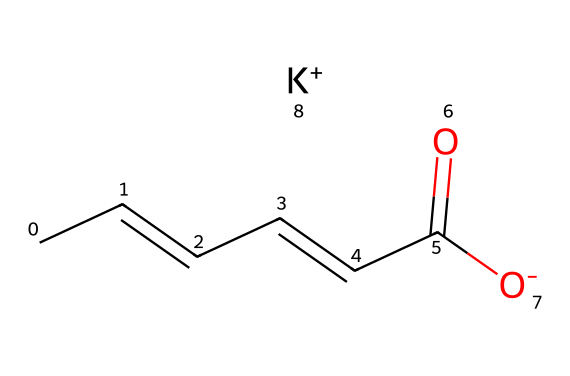What is the name of this chemical? The structural formula provided corresponds to a chemical known as potassium sorbate, which is commonly used as a preservative.
Answer: potassium sorbate How many carbon atoms are in potassium sorbate? By analyzing the SMILES representation, we can count the "C" labels, which indicate the presence of carbon atoms. In this case, there are 6 carbon atoms present in the structure of potassium sorbate.
Answer: 6 What type of bonds are primarily present in potassium sorbate? The structure shows a combination of double bonds (C=C) and single bonds between the carbon atoms, as well as a carboxyl group. Therefore, the primary bonds are carbon-carbon double bonds and carbon-oxygen bonds.
Answer: double bonds Which functional group is present in potassium sorbate? The "-COO-" (carboxylate) part of the structure indicates the presence of a carboxylic acid functional group in its deprotonated form, thus identifying it as a carboxylate.
Answer: carboxylate Why is potassium sorbate considered a preservative? Potassium sorbate inhibits the growth of mold and yeast due to its ability to disrupt the cell membranes of microorganisms, making it effective for extending the shelf life of food products.
Answer: it inhibits microbial growth Does potassium sorbate have any impact on flavor? As a preservative, potassium sorbate is generally regarded as flavor-neutral but can have a slight effect if used in high concentrations. Therefore, it does not typically impart any distinct flavor.
Answer: flavor-neutral 